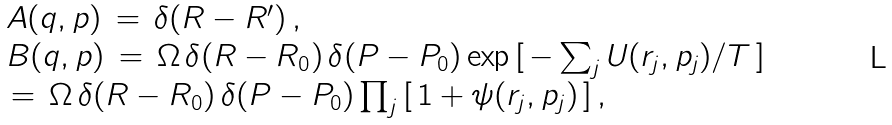<formula> <loc_0><loc_0><loc_500><loc_500>\begin{array} { l } A ( { q } , { p } ) \, = \, \delta ( { R } - { R } ^ { \prime } ) \, , \\ B ( { q } , { p } ) \, = \, \Omega \, \delta ( { R } - { R } _ { 0 } ) \, \delta ( { P } - { P } _ { 0 } ) \exp { [ \, - \sum _ { j } U ( { r } _ { j } , { p } _ { j } ) / T \, ] } \, \\ \, = \, \Omega \, \delta ( { R } - { R } _ { 0 } ) \, \delta ( { P } - { P } _ { 0 } ) \prod _ { j } \, [ \, 1 + \psi ( { r } _ { j } , { p } _ { j } ) \, ] \, , \end{array}</formula> 